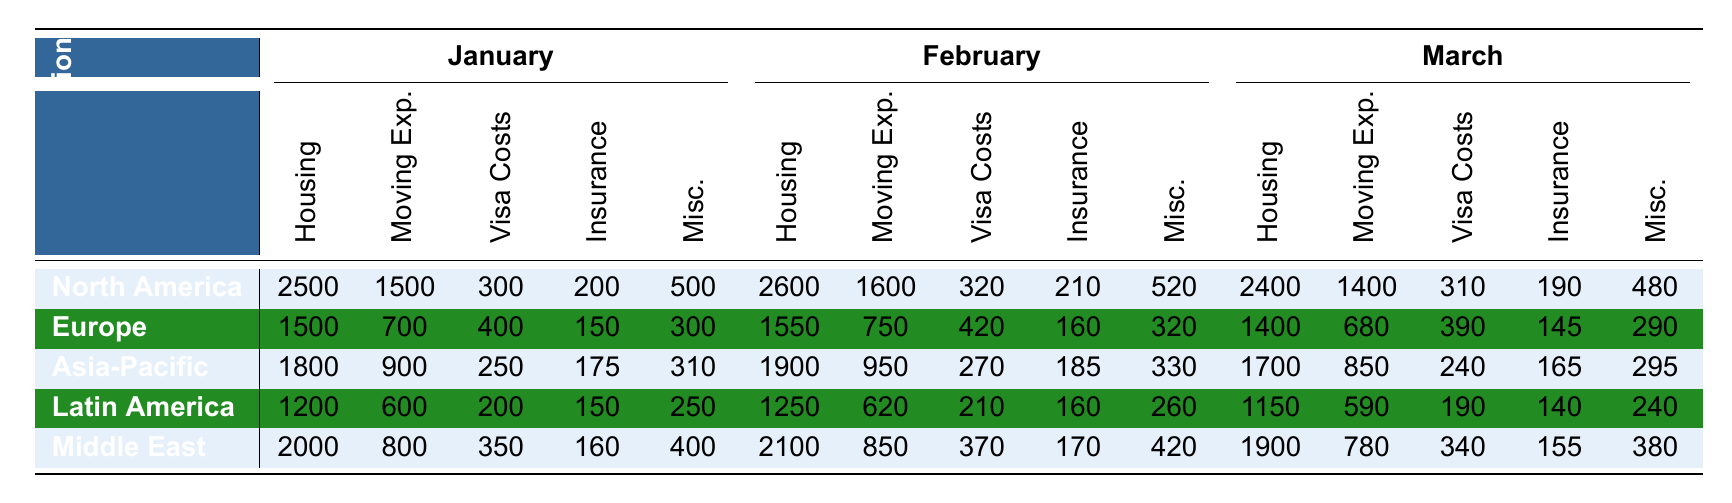What are the total relocation costs for North America in January? To find the total relocation costs for North America in January, we sum the costs of Housing (2500), Moving Expenses (1500), Visa Costs (300), Insurance (200), and Miscellaneous (500). The total is 2500 + 1500 + 300 + 200 + 500 = 5000.
Answer: 5000 Which region had the highest visa costs in February? Looking at the visa costs for February, North America has 320, Europe has 420, Asia-Pacific has 270, Latin America has 210, and the Middle East has 370. The highest is Europe with 420.
Answer: Europe What is the average housing cost across all regions for March? To calculate the average housing cost for March, we add the housing costs for all regions: North America (2400), Europe (1400), Asia-Pacific (1700), Latin America (1150), Middle East (1900). The sum is 2400 + 1400 + 1700 + 1150 + 1900 = 10550. There are 5 regions, so we divide by 5: 10550 / 5 = 2110.
Answer: 2110 Is the total moving expense in Asia-Pacific for March greater than that in Latin America for the same month? The moving expense in Asia-Pacific for March is 850, and in Latin America, it is 590. Since 850 is greater than 590, the statement is true.
Answer: Yes How much did the Middle East spend on Miscellaneous expenses in January compared to the average across all regions for the same month? The Middle East spent 400 on Miscellaneous expenses in January. Now, we find the average for January by summing the Miscellaneous costs: North America (500), Europe (300), Asia-Pacific (310), Latin America (250), and Middle East (400). The average is (500 + 300 + 310 + 250 + 400) / 5 = 2260 / 5 = 452. Since 400 is less than 452, the answer is no.
Answer: No What is the difference in total costs between Europe and North America for February? First, calculate total costs for each region in February. North America: 2600 (Housing) + 1600 (Moving) + 320 (Visa) + 210 (Insurance) + 520 (Miscellaneous) = 5260. Europe: 1550 + 750 + 420 + 160 + 320 = 3200. The difference is 5260 - 3200 = 2060.
Answer: 2060 What region had the lowest total relocation costs in March? Calculate the total for each region in March. North America: 2400 + 1400 + 310 + 190 + 480 = 4780. Europe: 1400 + 680 + 390 + 145 + 290 = 2905. Asia-Pacific: 1700 + 850 + 240 + 165 + 295 = 3220. Latin America: 1150 + 590 + 190 + 140 + 240 = 2300. Middle East: 1900 + 780 + 340 + 155 + 380 = 3555. The lowest total is for Latin America at 2300.
Answer: Latin America What is the increase in housing costs from January to February for Asia-Pacific? For January, Asia-Pacific's housing cost is 1800 and in February, it's 1900. The increase is 1900 - 1800 = 100.
Answer: 100 Are insurance costs in North America for January equal to those in the Middle East for the same month? In January, North America's insurance cost is 200, and Middle East is 160. Since 200 is not equal to 160, the statement is false.
Answer: No How much did Latin America spend on Moving Expenses in January compared to the average of all regions? Latin America spent 600 on Moving Expenses in January. The average can be calculated: 1500 (North America) + 700 (Europe) + 900 (Asia-Pacific) + 600 (Latin America) + 800 (Middle East) = 3700 / 5 = 740. Since 600 is less than 740, the answer is no.
Answer: No 